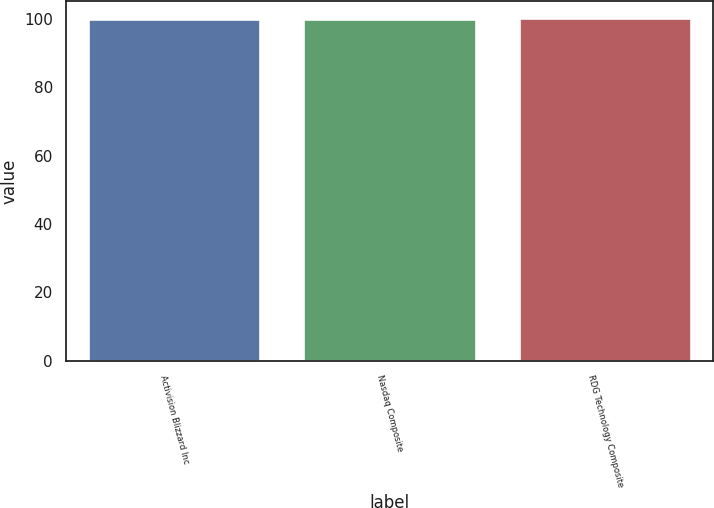<chart> <loc_0><loc_0><loc_500><loc_500><bar_chart><fcel>Activision Blizzard Inc<fcel>Nasdaq Composite<fcel>RDG Technology Composite<nl><fcel>100<fcel>100.1<fcel>100.2<nl></chart> 